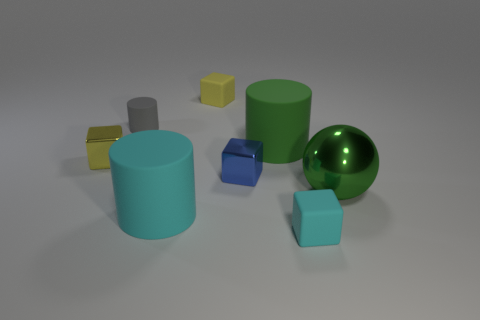Describe the composition and arrangement of the objects. The image displays a collection of geometric shapes scattered across a flat surface. You'll notice two cylinders--a green one and a gray one, a metallic ball, and a cluster of smaller shapes that include a yellow cube, a blue cube, and a small cyan cube, all varying in size and positioned sporadically. 